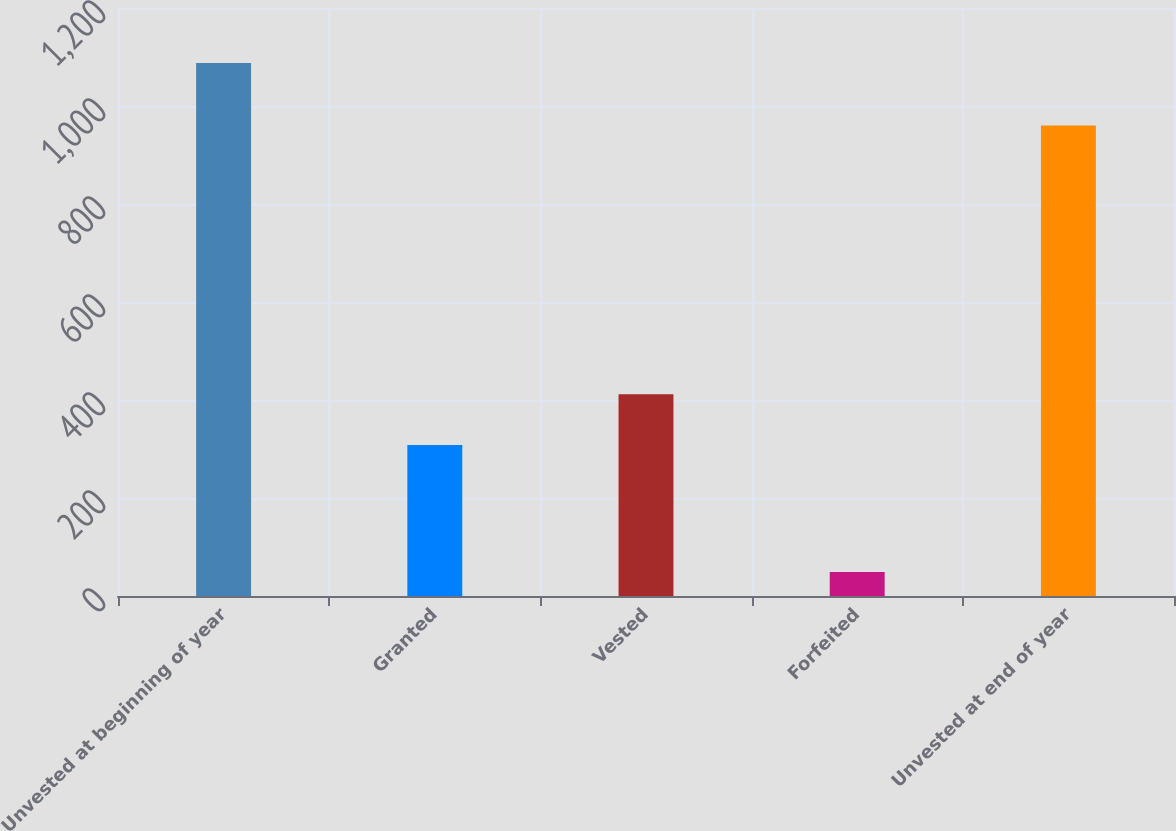Convert chart. <chart><loc_0><loc_0><loc_500><loc_500><bar_chart><fcel>Unvested at beginning of year<fcel>Granted<fcel>Vested<fcel>Forfeited<fcel>Unvested at end of year<nl><fcel>1088<fcel>308<fcel>411.9<fcel>49<fcel>960<nl></chart> 